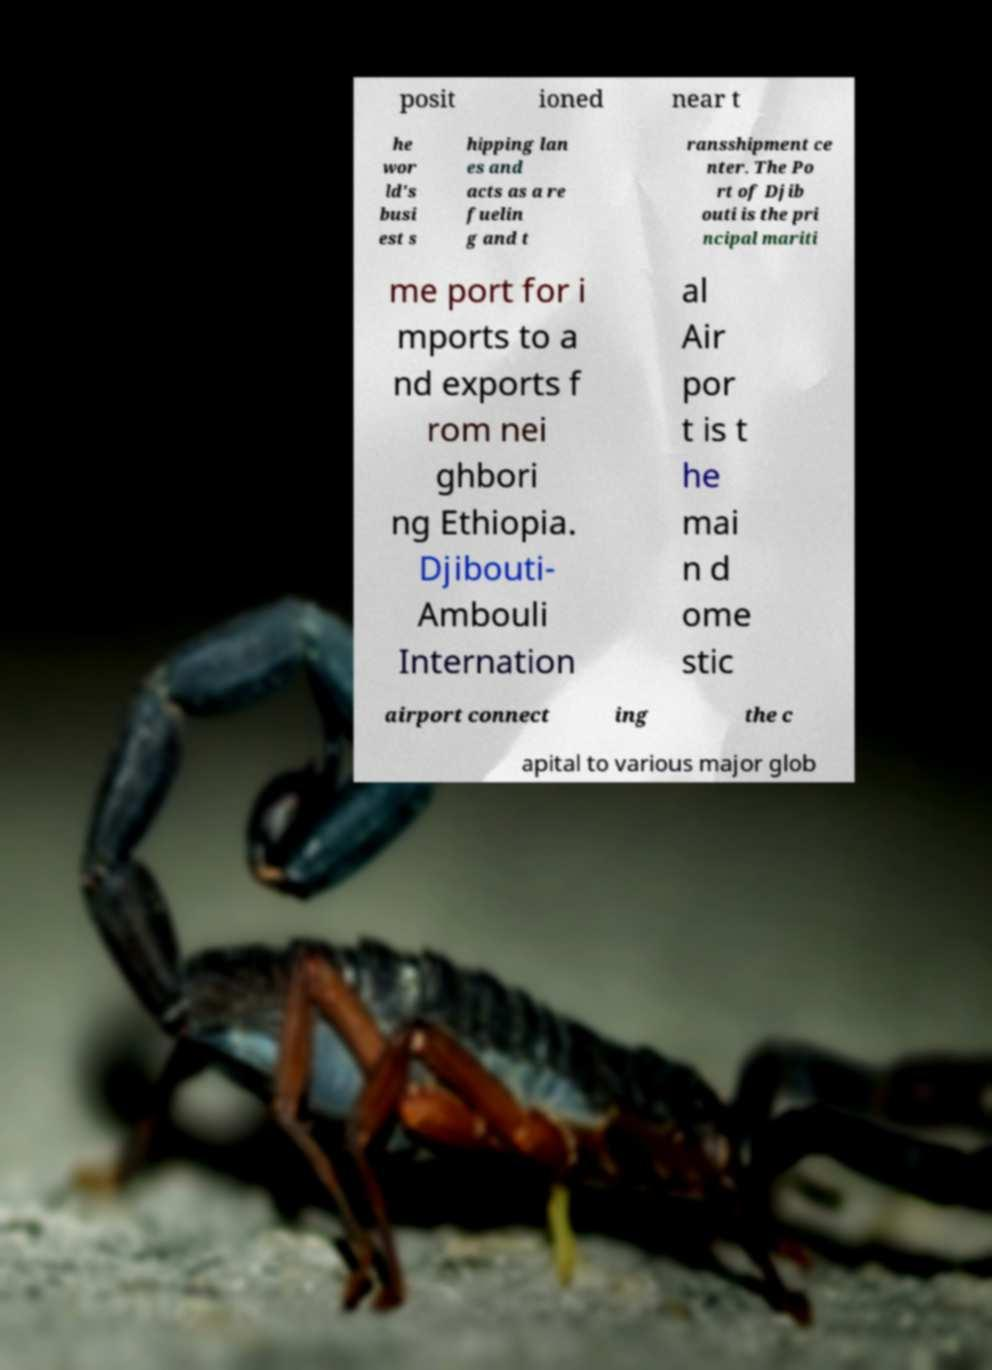Can you read and provide the text displayed in the image?This photo seems to have some interesting text. Can you extract and type it out for me? posit ioned near t he wor ld's busi est s hipping lan es and acts as a re fuelin g and t ransshipment ce nter. The Po rt of Djib outi is the pri ncipal mariti me port for i mports to a nd exports f rom nei ghbori ng Ethiopia. Djibouti- Ambouli Internation al Air por t is t he mai n d ome stic airport connect ing the c apital to various major glob 